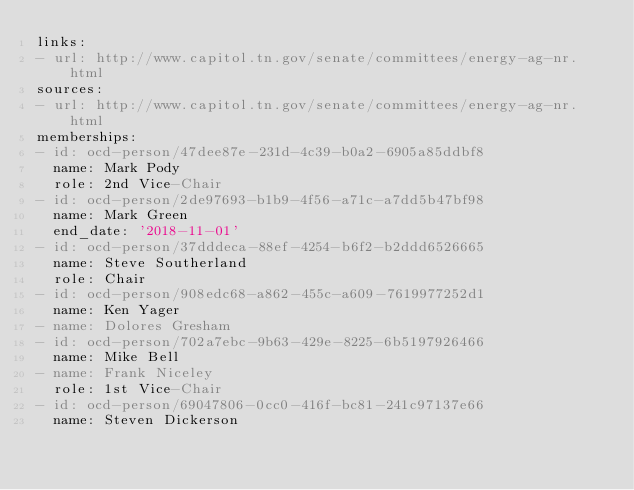Convert code to text. <code><loc_0><loc_0><loc_500><loc_500><_YAML_>links:
- url: http://www.capitol.tn.gov/senate/committees/energy-ag-nr.html
sources:
- url: http://www.capitol.tn.gov/senate/committees/energy-ag-nr.html
memberships:
- id: ocd-person/47dee87e-231d-4c39-b0a2-6905a85ddbf8
  name: Mark Pody
  role: 2nd Vice-Chair
- id: ocd-person/2de97693-b1b9-4f56-a71c-a7dd5b47bf98
  name: Mark Green
  end_date: '2018-11-01'
- id: ocd-person/37dddeca-88ef-4254-b6f2-b2ddd6526665
  name: Steve Southerland
  role: Chair
- id: ocd-person/908edc68-a862-455c-a609-7619977252d1
  name: Ken Yager
- name: Dolores Gresham
- id: ocd-person/702a7ebc-9b63-429e-8225-6b5197926466
  name: Mike Bell
- name: Frank Niceley
  role: 1st Vice-Chair
- id: ocd-person/69047806-0cc0-416f-bc81-241c97137e66
  name: Steven Dickerson
</code> 